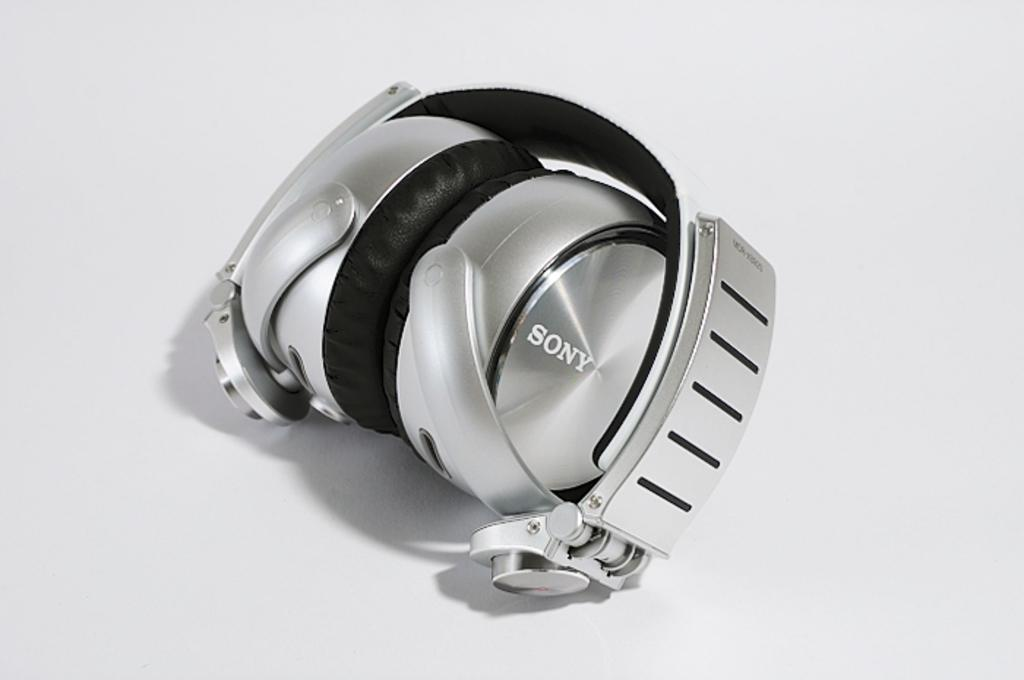<image>
Share a concise interpretation of the image provided. A pair of chrome silver headphones from Sony that fold down. 